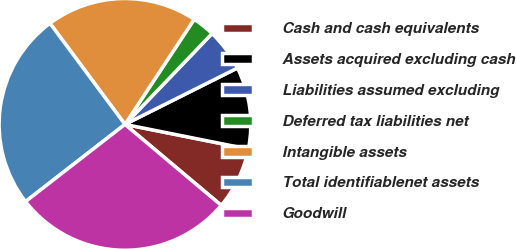Convert chart. <chart><loc_0><loc_0><loc_500><loc_500><pie_chart><fcel>Cash and cash equivalents<fcel>Assets acquired excluding cash<fcel>Liabilities assumed excluding<fcel>Deferred tax liabilities net<fcel>Intangible assets<fcel>Total identifiablenet assets<fcel>Goodwill<nl><fcel>7.99%<fcel>10.53%<fcel>5.44%<fcel>2.89%<fcel>19.43%<fcel>25.35%<fcel>28.36%<nl></chart> 